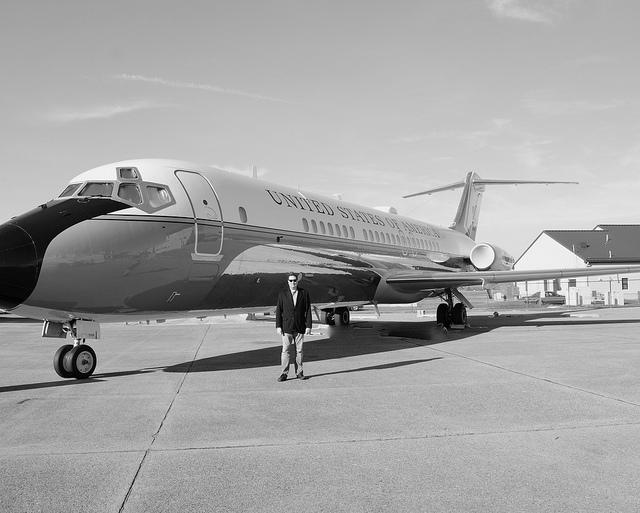How many wheels does the airplane have?
Concise answer only. 6. What kind of aircraft is this?
Keep it brief. Plane. What is the man standing next to?
Answer briefly. Plane. Is the plane very colorful?
Give a very brief answer. No. How Many Wheels are on the plane?
Be succinct. 6. 